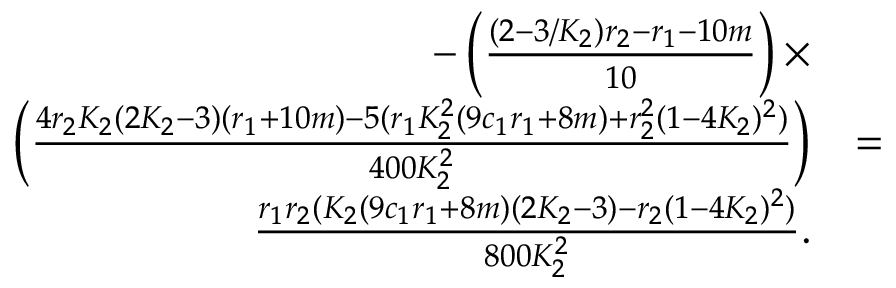<formula> <loc_0><loc_0><loc_500><loc_500>\begin{array} { r l r } { - \left ( \frac { ( 2 - 3 / K _ { 2 } ) r _ { 2 } - r _ { 1 } - 1 0 m } { 1 0 } \right ) \times } & \\ { \left ( \frac { 4 r _ { 2 } K _ { 2 } ( 2 K _ { 2 } - 3 ) ( r _ { 1 } + 1 0 m ) - 5 ( r _ { 1 } K _ { 2 } ^ { 2 } ( 9 c _ { 1 } r _ { 1 } + 8 m ) + r _ { 2 } ^ { 2 } ( 1 - 4 K _ { 2 } ) ^ { 2 } ) } { 4 0 0 K _ { 2 } ^ { 2 } } \right ) } & { = } & \\ { \frac { r _ { 1 } r _ { 2 } ( K _ { 2 } ( 9 c _ { 1 } r _ { 1 } + 8 m ) ( 2 K _ { 2 } - 3 ) - r _ { 2 } ( 1 - 4 K _ { 2 } ) ^ { 2 } ) } { 8 0 0 K _ { 2 } ^ { 2 } } . } \end{array}</formula> 